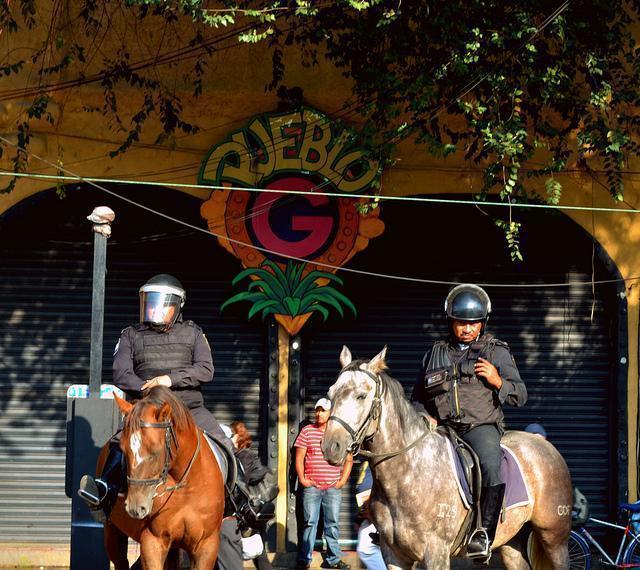What is the profession of the men on horses?
From the following four choices, select the correct answer to address the question.
Options: Waiter, officer, priest, doctor. Officer. 